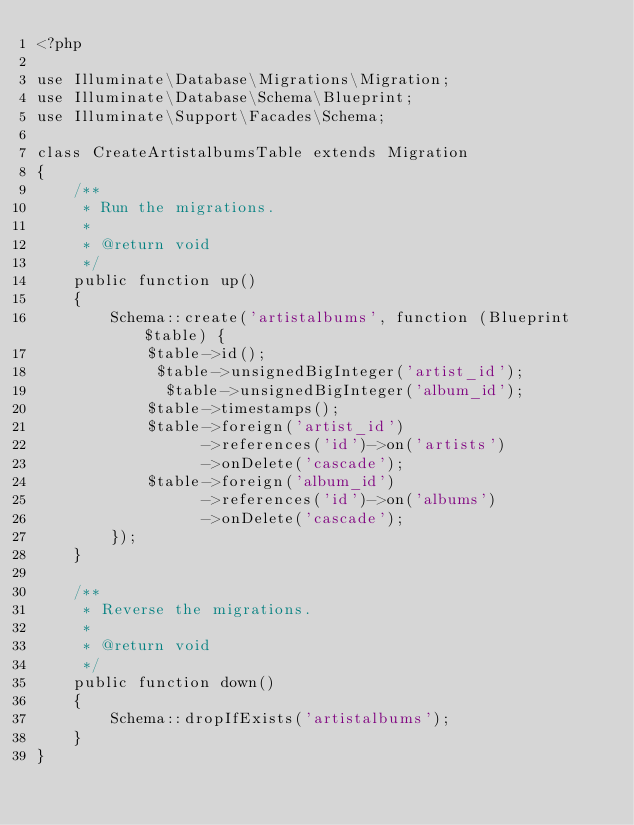Convert code to text. <code><loc_0><loc_0><loc_500><loc_500><_PHP_><?php

use Illuminate\Database\Migrations\Migration;
use Illuminate\Database\Schema\Blueprint;
use Illuminate\Support\Facades\Schema;

class CreateArtistalbumsTable extends Migration
{
    /**
     * Run the migrations.
     *
     * @return void
     */
    public function up()
    {
        Schema::create('artistalbums', function (Blueprint $table) {
            $table->id();
             $table->unsignedBigInteger('artist_id');
              $table->unsignedBigInteger('album_id');
            $table->timestamps();
            $table->foreign('artist_id')
                  ->references('id')->on('artists')
                  ->onDelete('cascade'); 
            $table->foreign('album_id')
                  ->references('id')->on('albums')
                  ->onDelete('cascade'); 
        });
    }

    /**
     * Reverse the migrations.
     *
     * @return void
     */
    public function down()
    {
        Schema::dropIfExists('artistalbums');
    }
}
</code> 